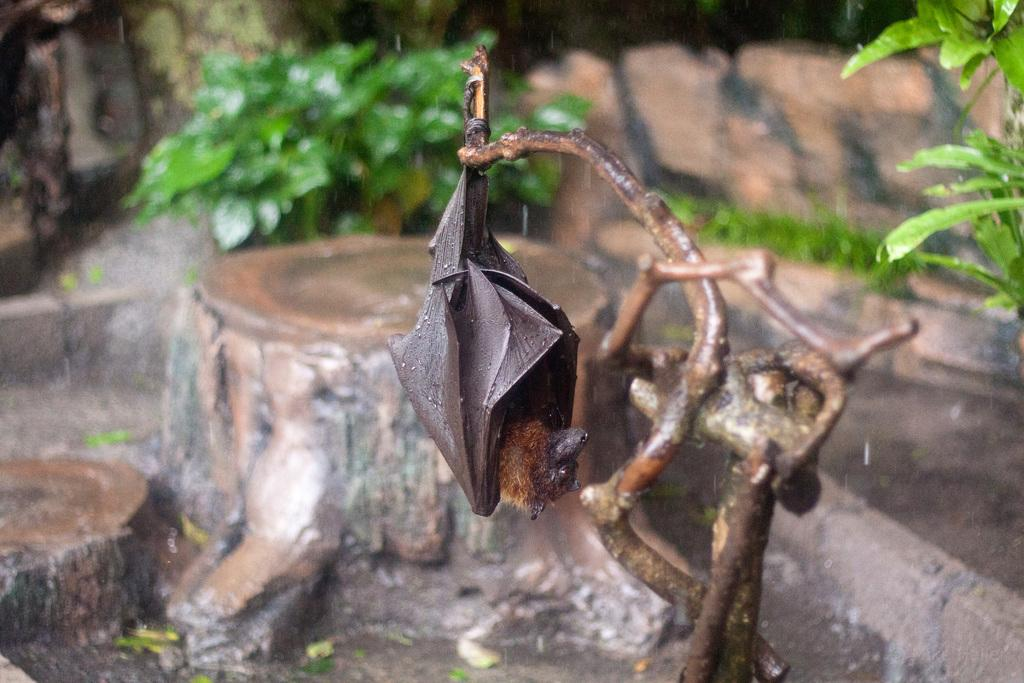What animal is present in the image? There is a bat in the image. How is the bat positioned in the image? The bat is hanging from a branch. What is the color of the bat? The bat is brown in color. What type of vegetation is visible in the image? There are plants in the image. Can you describe the background of the image? The background of the image is blurry. Can you see any ocean waves in the image? There is no ocean or waves present in the image; it features a bat hanging from a branch. Are there any bushes visible in the image? The provided facts do not mention bushes, but there are plants visible in the image. Is there an apple hanging from the branch with the bat? There is no apple present in the image; only the bat is hanging from the branch. 